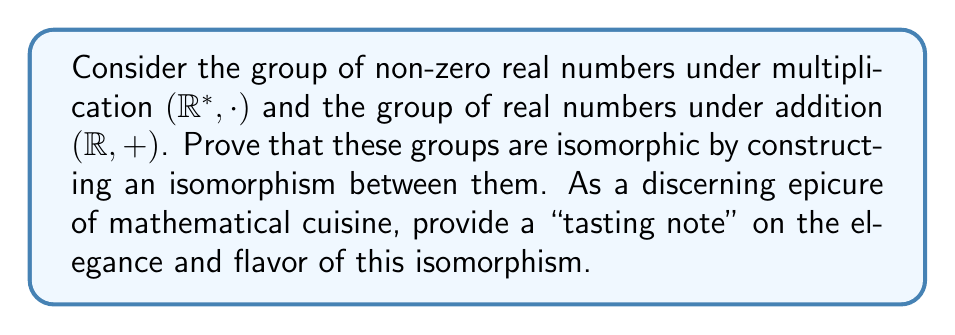Could you help me with this problem? Let's approach this proof with the refined palate of a mathematical connoisseur:

1) First, we need to define a function $f: R^* \to R$ that will serve as our potential isomorphism. A natural choice, given the structures involved, is the logarithm function:

   $f(x) = \ln(|x|)$ for $x \in R^*$

2) To prove this is an isomorphism, we need to show it is both a homomorphism and a bijection.

3) To show it's a homomorphism, we need to prove that $f(ab) = f(a) + f(b)$ for all $a, b \in R^*$:

   $f(ab) = \ln(|ab|) = \ln(|a||b|) = \ln(|a|) + \ln(|b|) = f(a) + f(b)$

4) To prove bijectivity, we need to show that $f$ is both injective (one-to-one) and surjective (onto):

   - Injective: If $f(a) = f(b)$, then $\ln(|a|) = \ln(|b|)$, which implies $|a| = |b|$. Since $a, b \in R^*$, this means $a = b$ or $a = -b$. But $f(a) = f(-a)$, so $a = b$ in $R^*$.

   - Surjective: For any $y \in R$, there exists an $x \in R^*$ such that $f(x) = y$. We can choose $x = e^y$ or $x = -e^y$.

5) Therefore, $f$ is an isomorphism between $(R^*, \cdot)$ and $(R, +)$.

Tasting note: This isomorphism has a delightful bouquet of elegance, transforming the multiplicative structure into an additive one with a logarithmic finesse. The natural logarithm serves as the perfect "reduction sauce", concentrating the essence of the group structure while preserving its fundamental flavor. A truly exquisite pairing of algebraic structures!
Answer: The groups $(R^*, \cdot)$ and $(R, +)$ are isomorphic via $f(x) = \ln(|x|)$. 